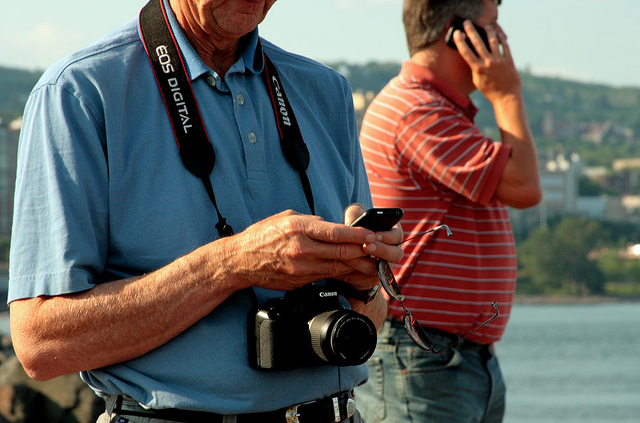How might the technology the man is using influence his experience of the event? The camera technology allows the man to capture and preserve moments from the event, which may encourage him to pay more attention to details and scenes worth photographing. On the flip side, he might become more focused on taking pictures than experiencing the event directly. Could you speculate about what kind of event he might be photographing? Given the setting, which seems to be outdoors, near water and during a pleasant day, he could be photographing a range of subjects such as a sailing race, a waterfront festival, or perhaps simply capturing the natural scenery and people around. 